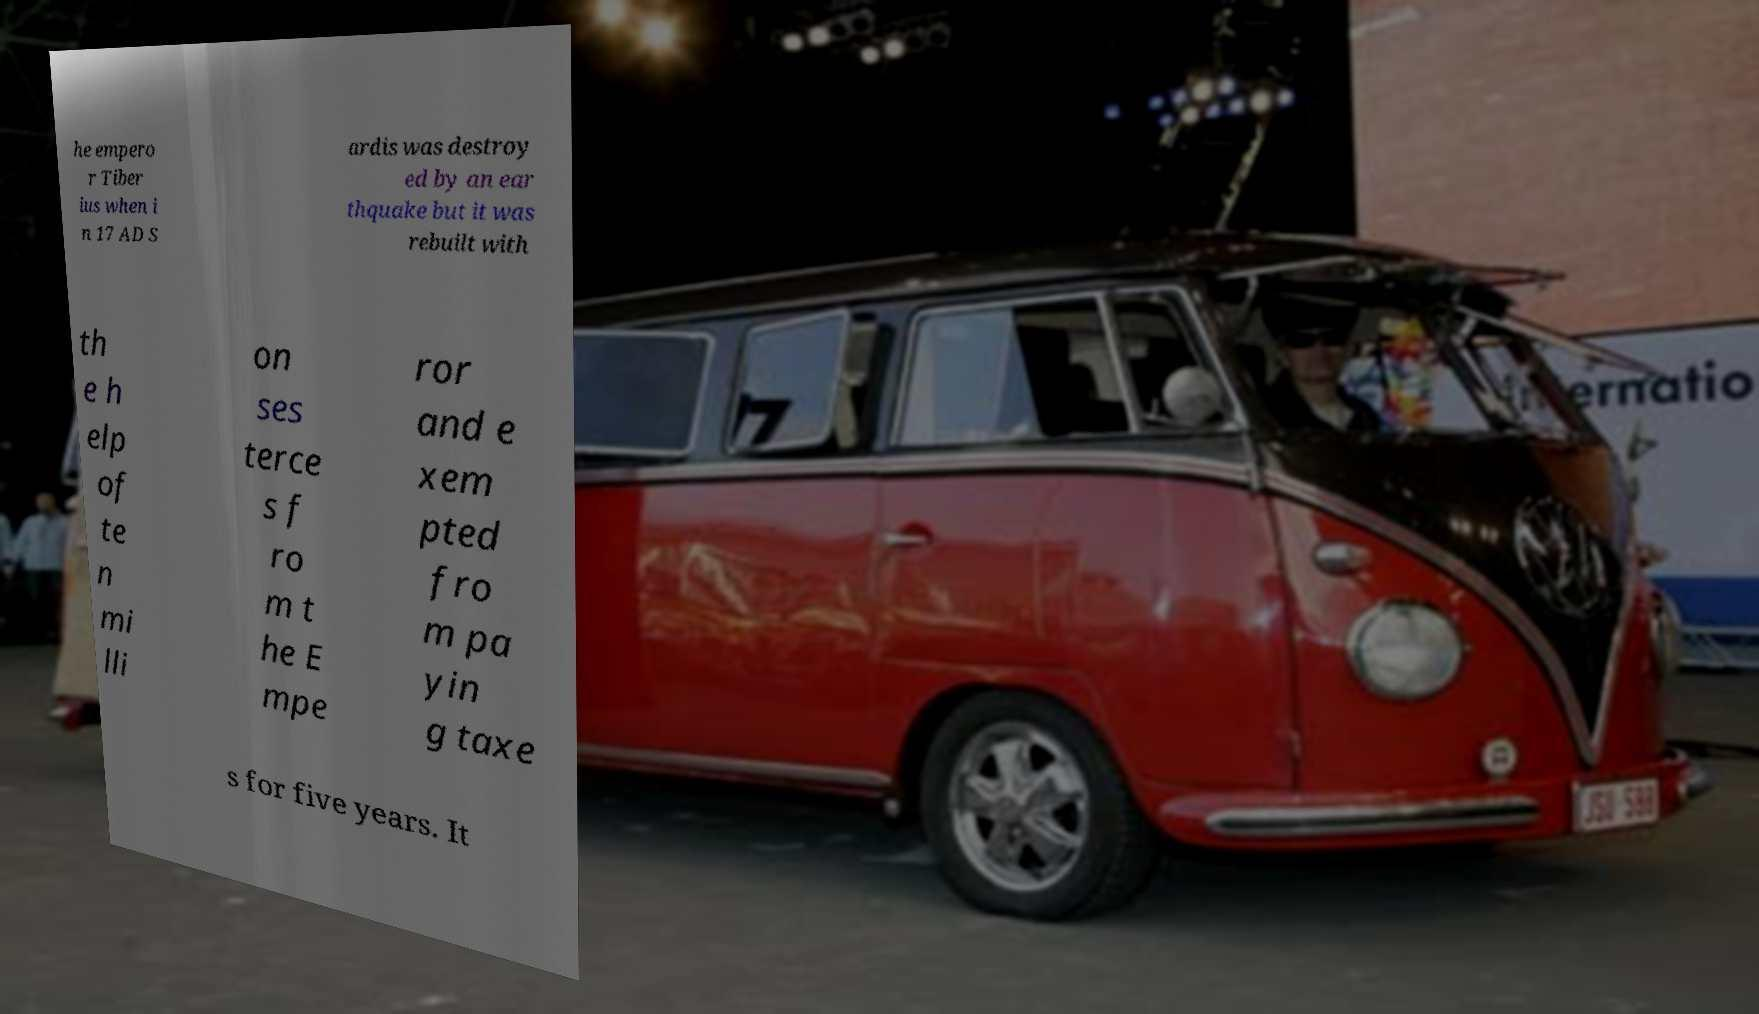What messages or text are displayed in this image? I need them in a readable, typed format. he empero r Tiber ius when i n 17 AD S ardis was destroy ed by an ear thquake but it was rebuilt with th e h elp of te n mi lli on ses terce s f ro m t he E mpe ror and e xem pted fro m pa yin g taxe s for five years. It 